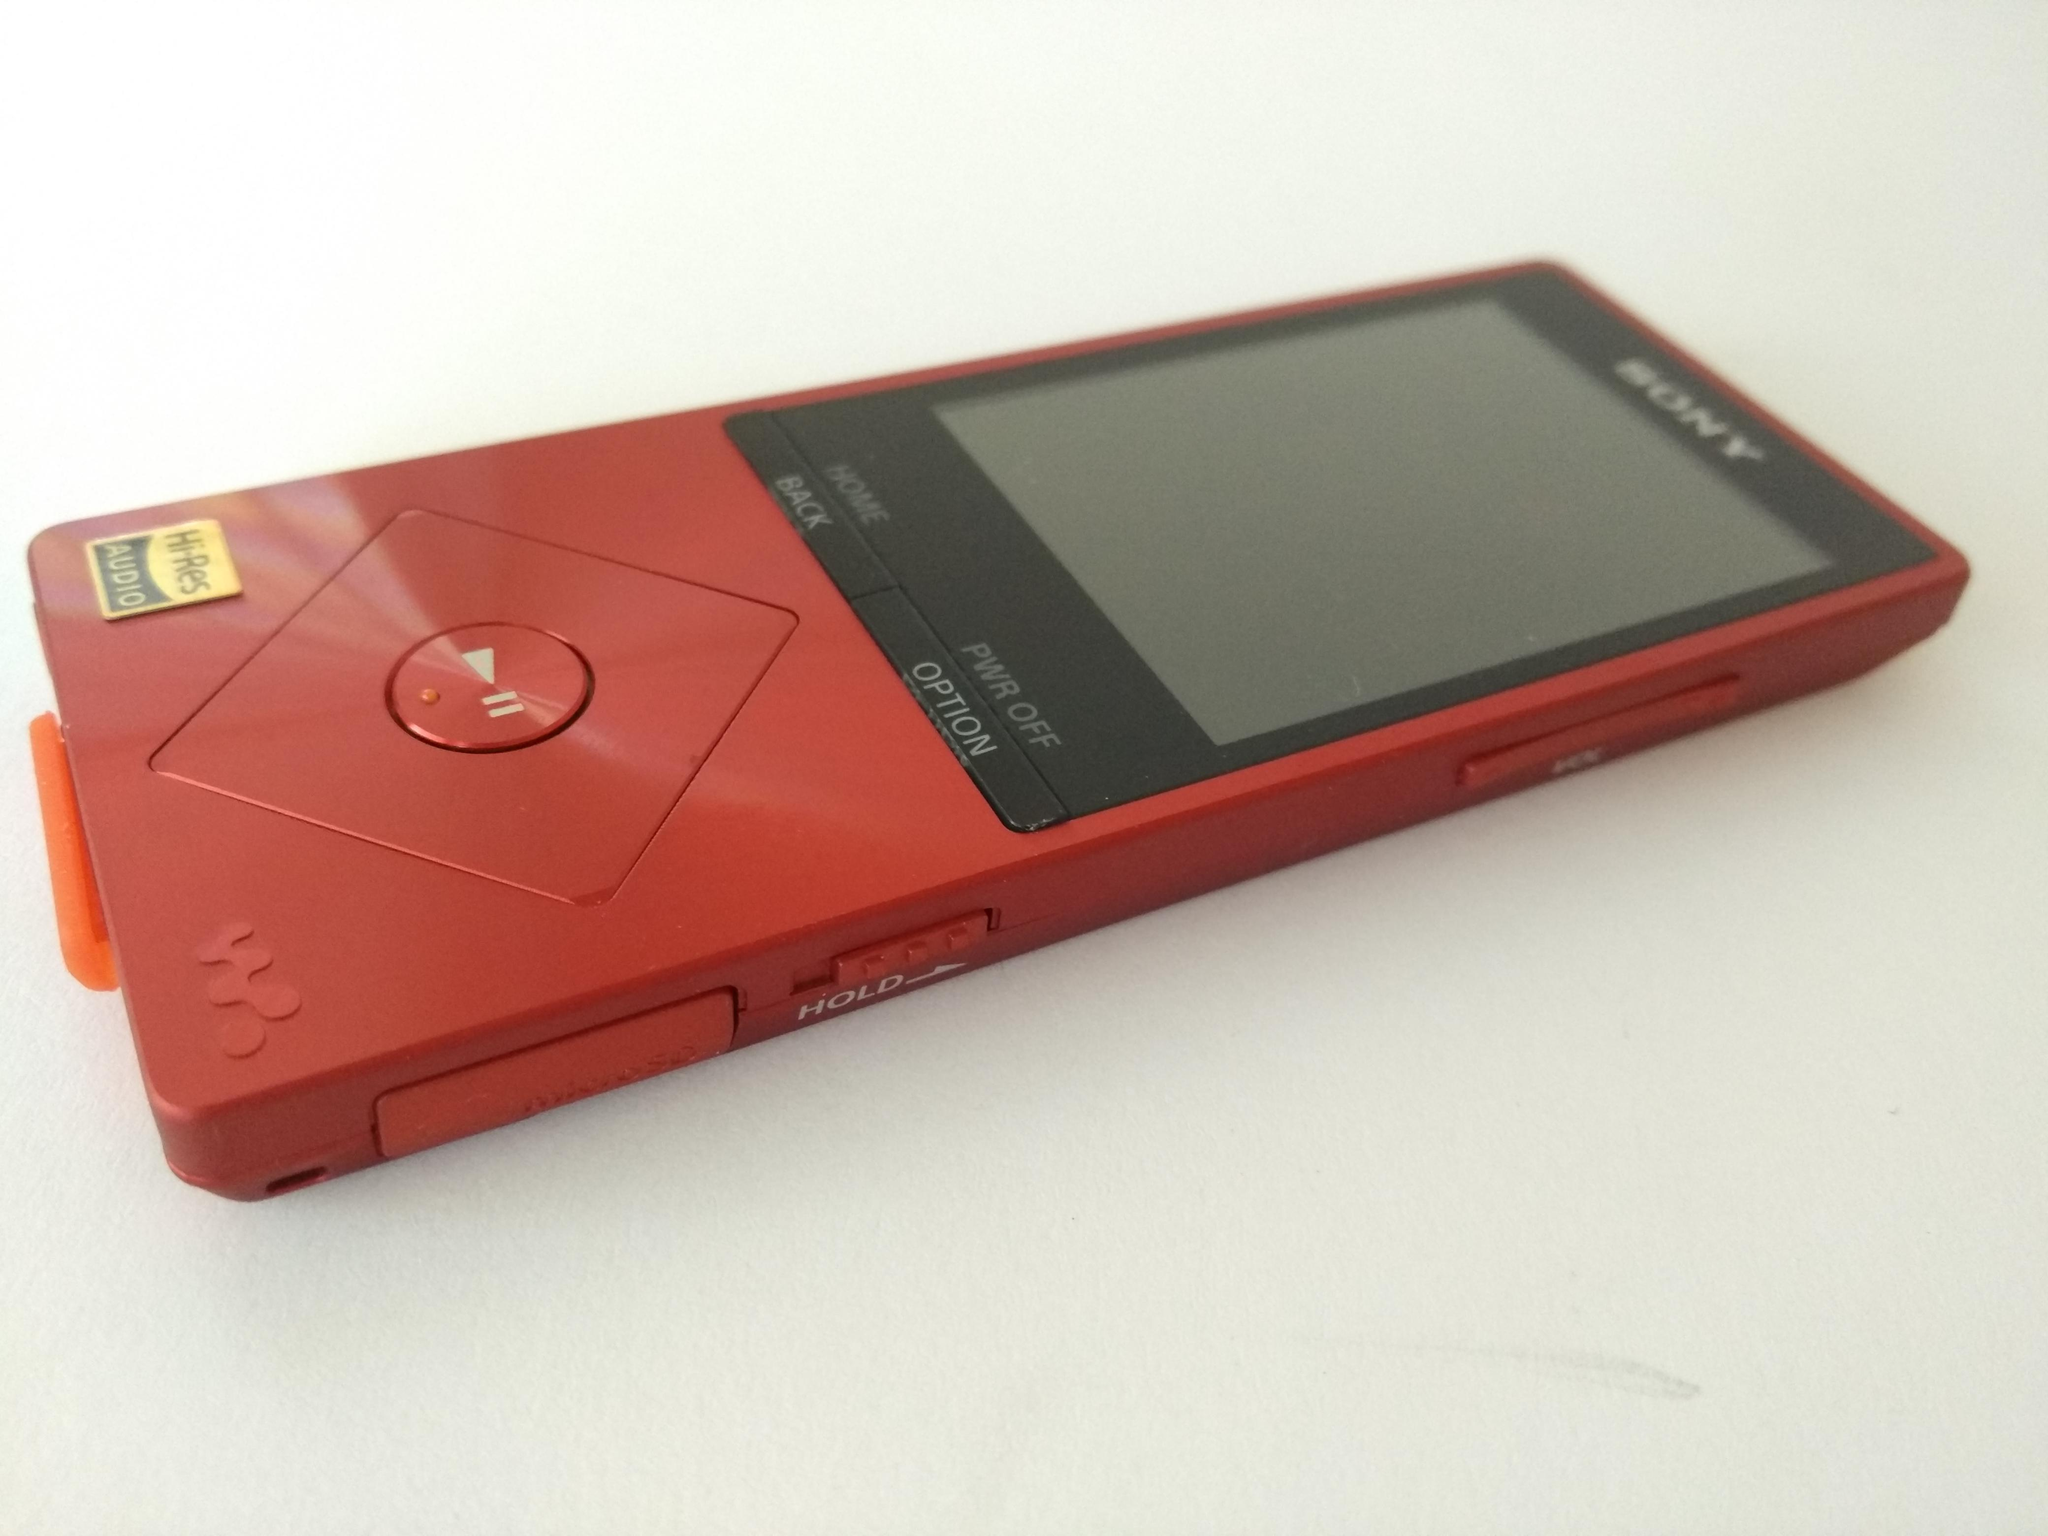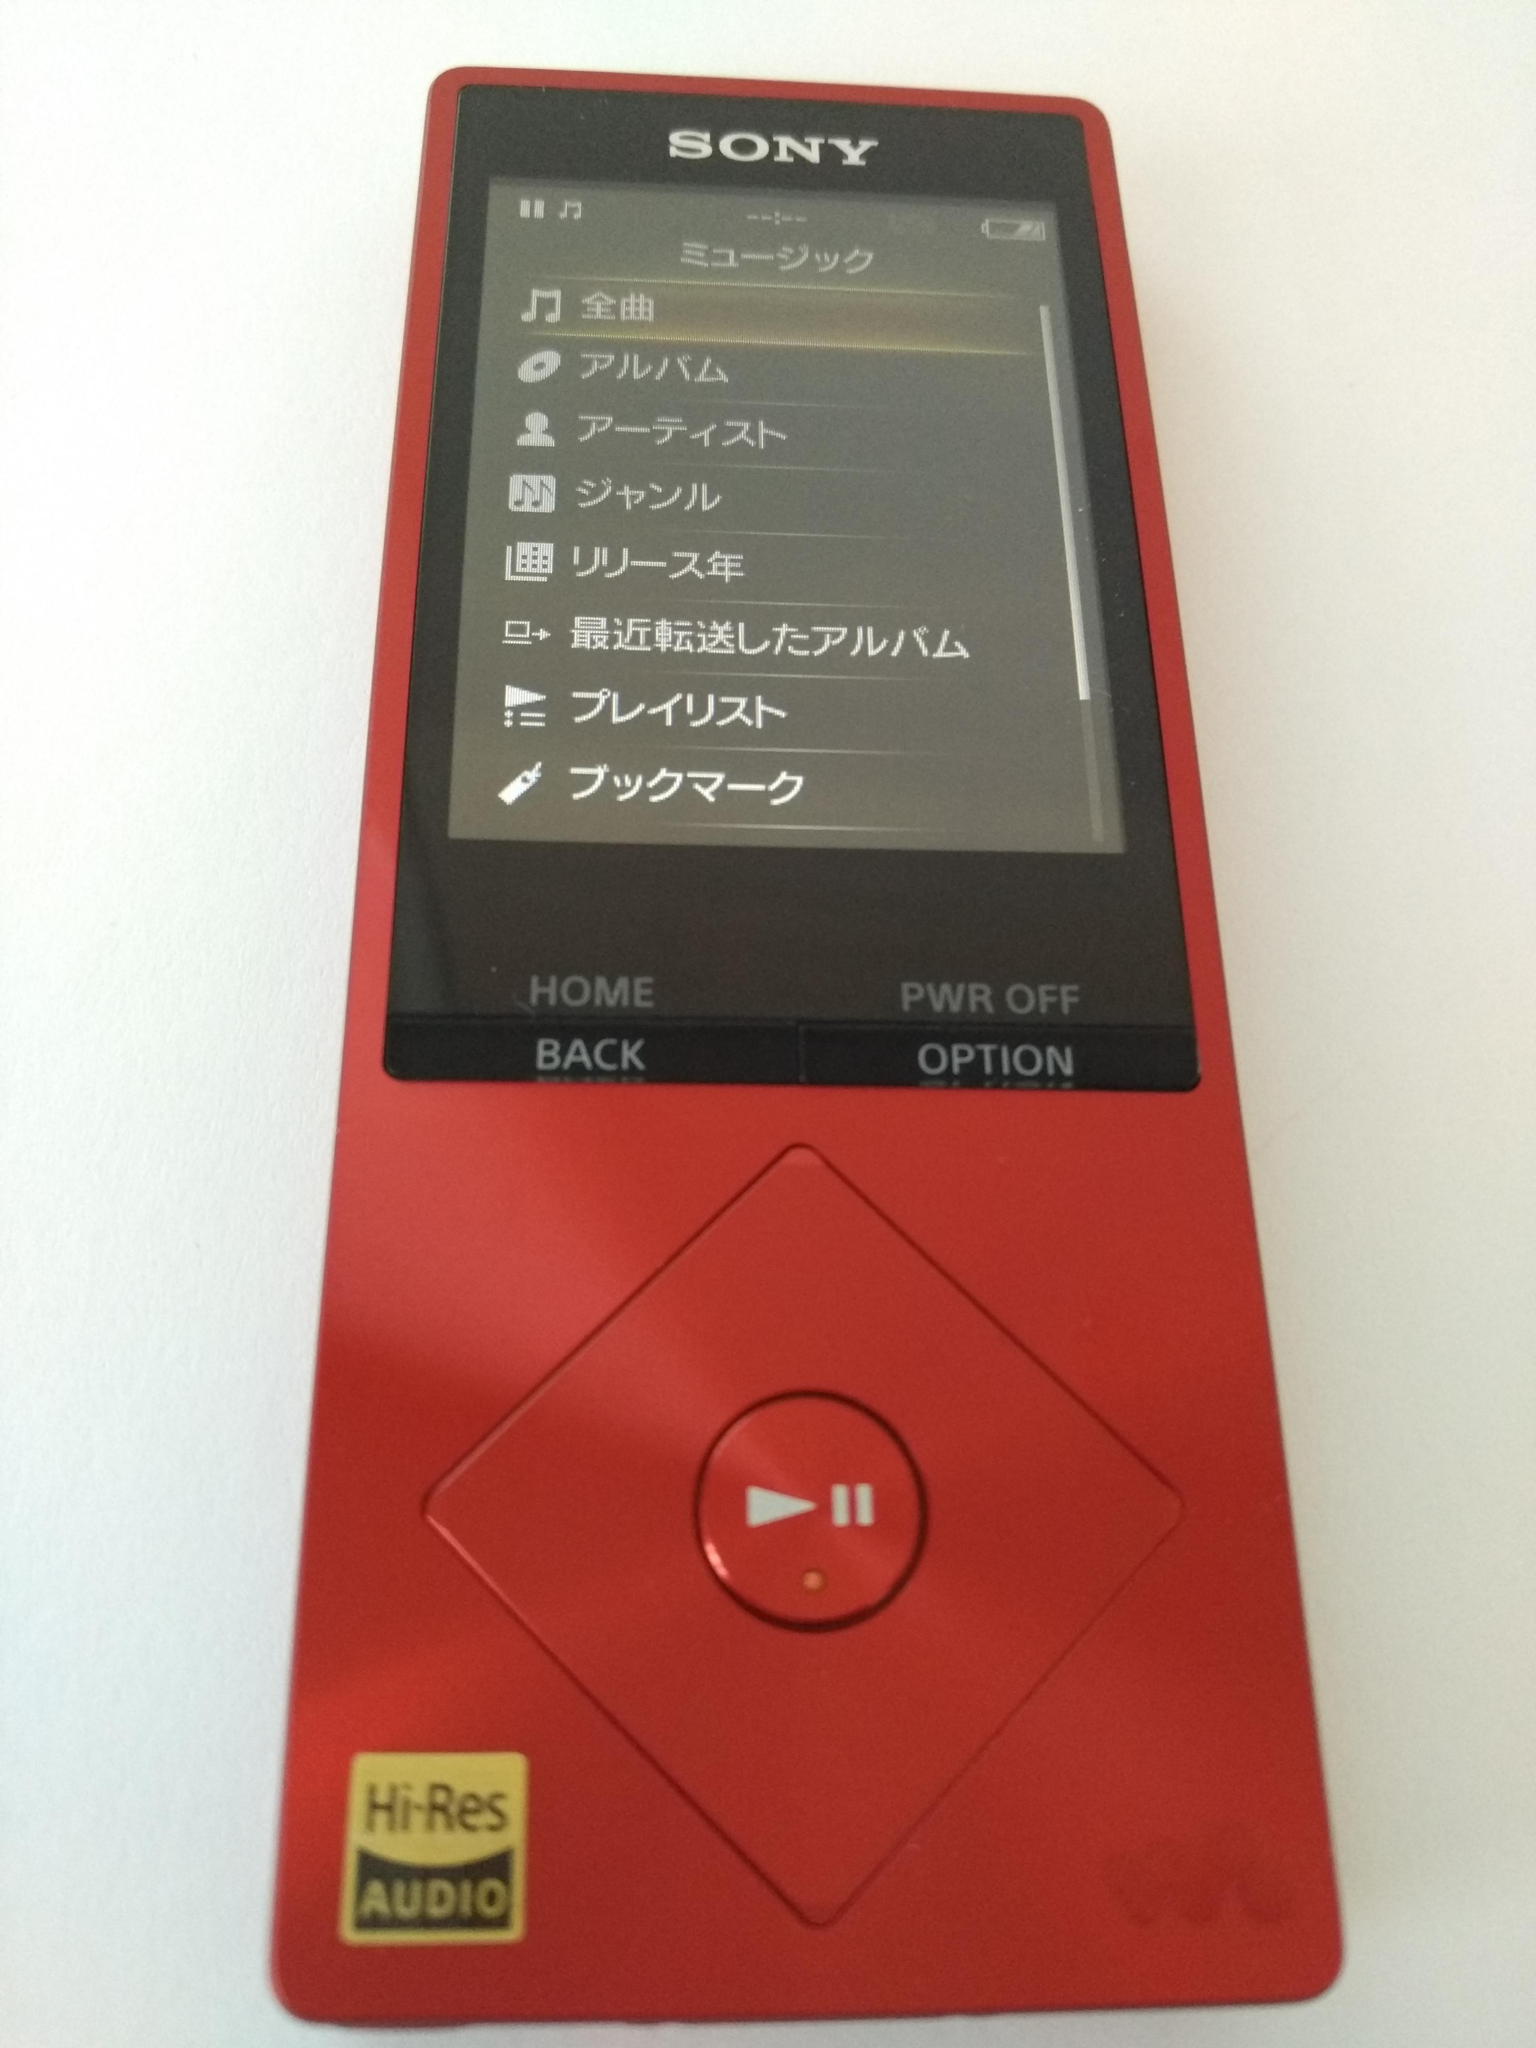The first image is the image on the left, the second image is the image on the right. Considering the images on both sides, is "Each image contains one red device, and at least one of the devices pictured has a round button inside a red diamond shape at the bottom." valid? Answer yes or no. Yes. The first image is the image on the left, the second image is the image on the right. Assess this claim about the two images: "One image shows the back of the phone.". Correct or not? Answer yes or no. No. 